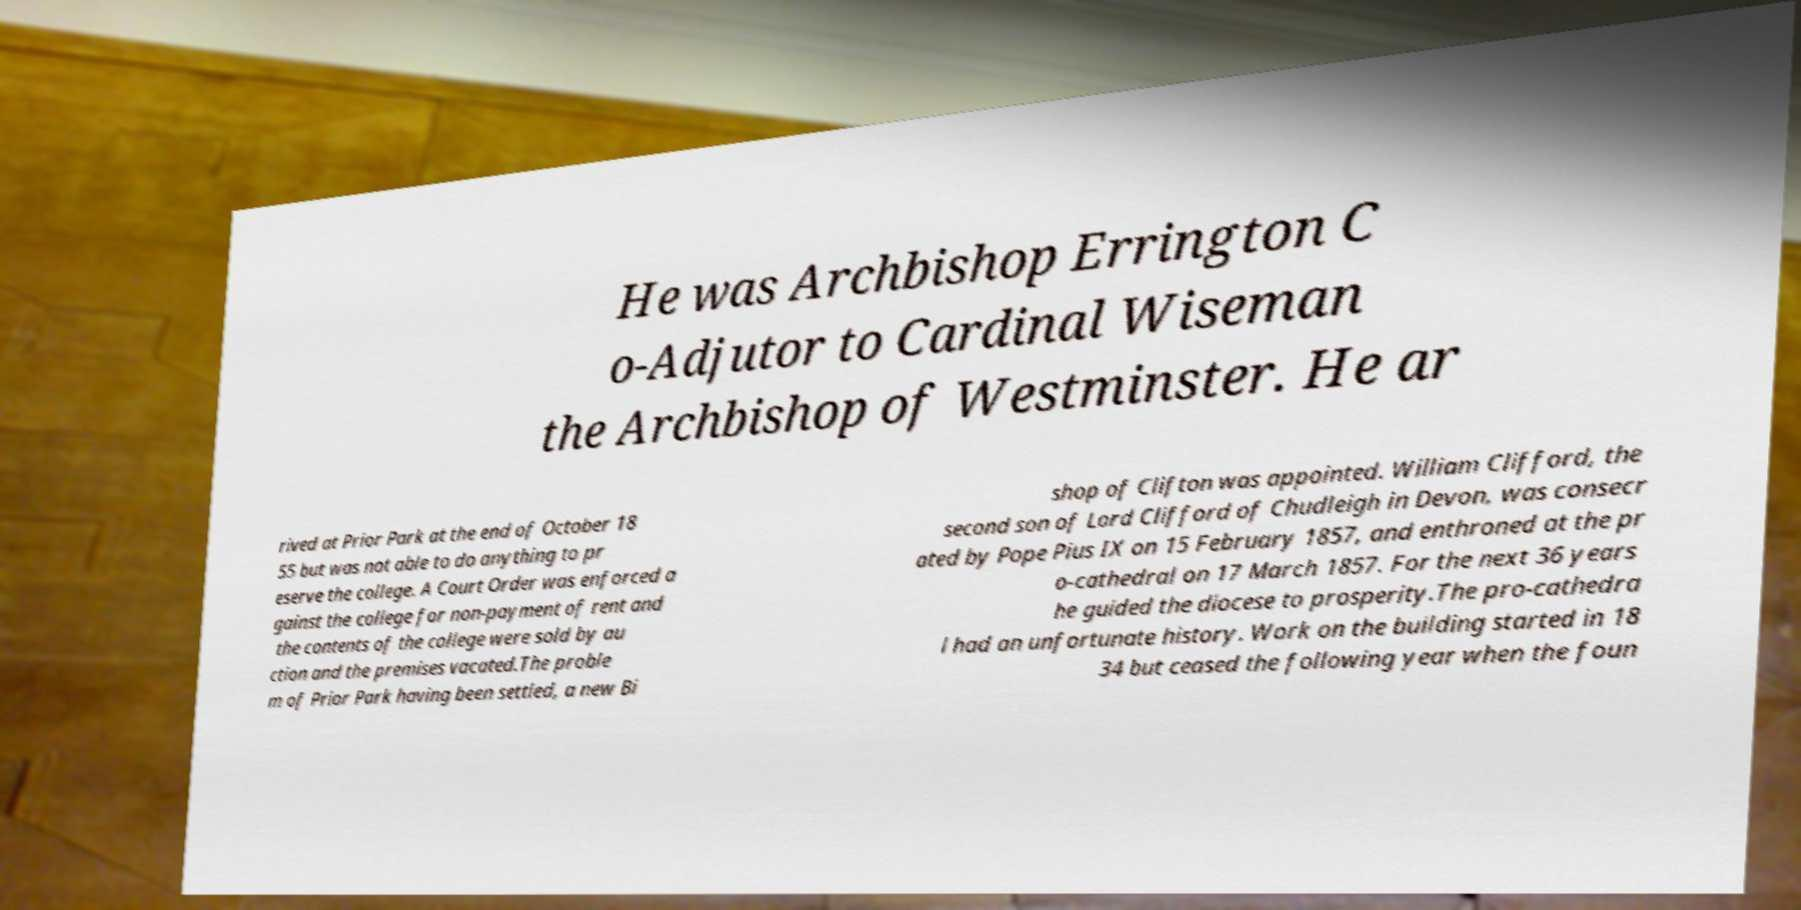There's text embedded in this image that I need extracted. Can you transcribe it verbatim? He was Archbishop Errington C o-Adjutor to Cardinal Wiseman the Archbishop of Westminster. He ar rived at Prior Park at the end of October 18 55 but was not able to do anything to pr eserve the college. A Court Order was enforced a gainst the college for non-payment of rent and the contents of the college were sold by au ction and the premises vacated.The proble m of Prior Park having been settled, a new Bi shop of Clifton was appointed. William Clifford, the second son of Lord Clifford of Chudleigh in Devon, was consecr ated by Pope Pius IX on 15 February 1857, and enthroned at the pr o-cathedral on 17 March 1857. For the next 36 years he guided the diocese to prosperity.The pro-cathedra l had an unfortunate history. Work on the building started in 18 34 but ceased the following year when the foun 